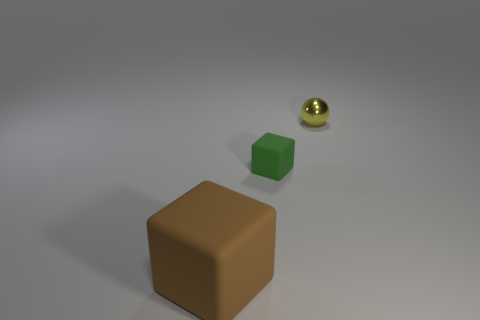Add 3 brown rubber cubes. How many objects exist? 6 Subtract all brown cubes. How many cubes are left? 1 Subtract all large brown rubber objects. Subtract all small green things. How many objects are left? 1 Add 2 large brown rubber things. How many large brown rubber things are left? 3 Add 2 large yellow cubes. How many large yellow cubes exist? 2 Subtract 0 green spheres. How many objects are left? 3 Subtract all cubes. How many objects are left? 1 Subtract all brown blocks. Subtract all blue cylinders. How many blocks are left? 1 